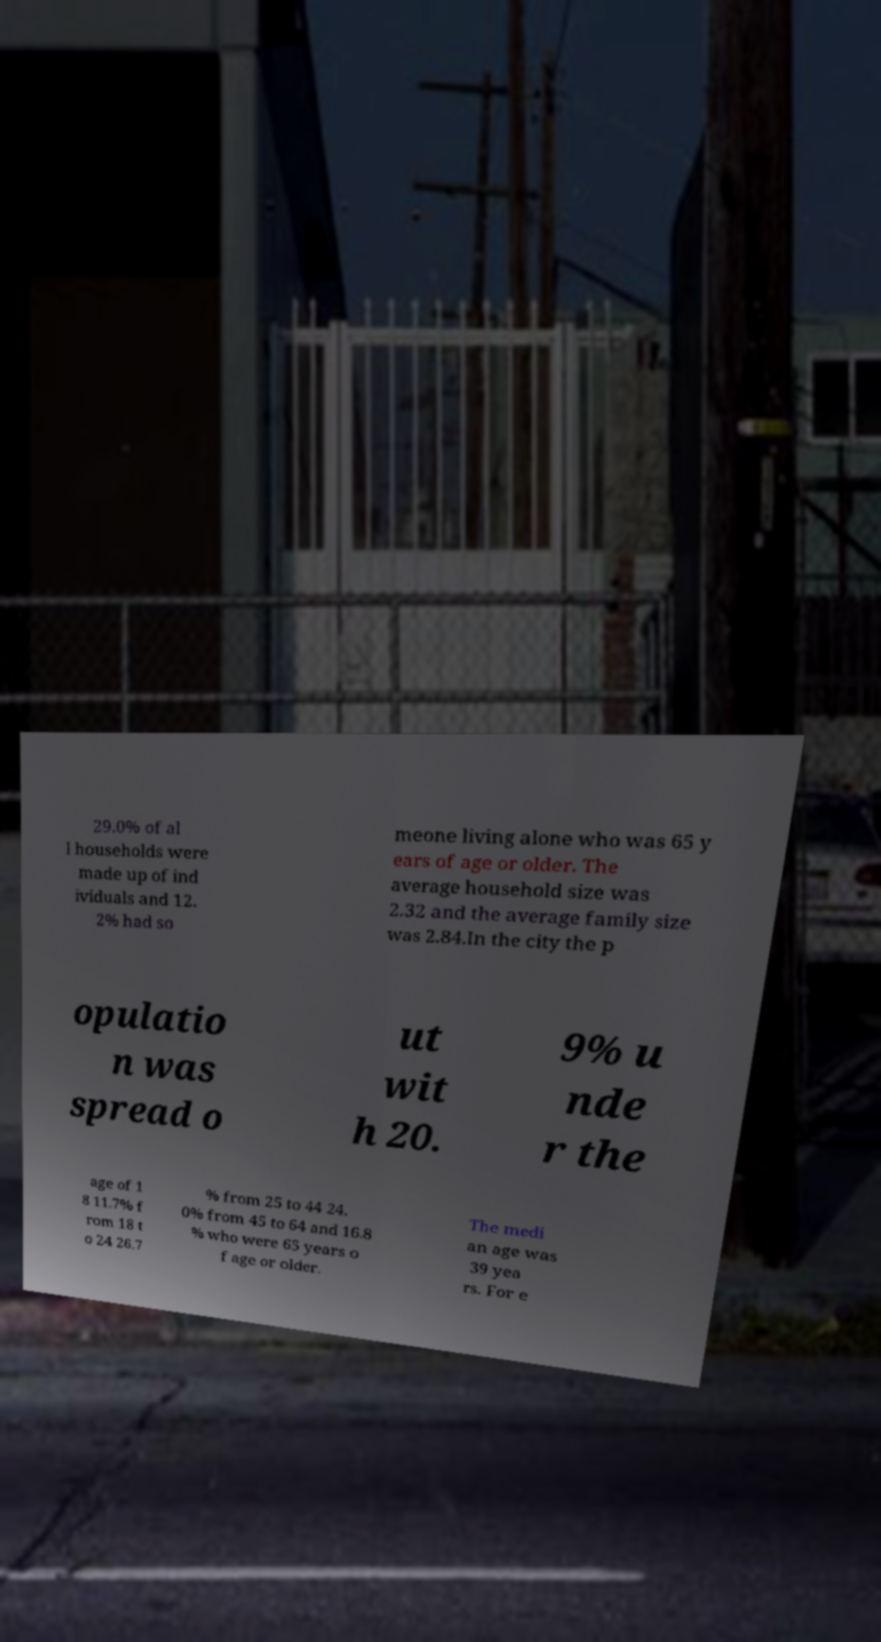For documentation purposes, I need the text within this image transcribed. Could you provide that? 29.0% of al l households were made up of ind ividuals and 12. 2% had so meone living alone who was 65 y ears of age or older. The average household size was 2.32 and the average family size was 2.84.In the city the p opulatio n was spread o ut wit h 20. 9% u nde r the age of 1 8 11.7% f rom 18 t o 24 26.7 % from 25 to 44 24. 0% from 45 to 64 and 16.8 % who were 65 years o f age or older. The medi an age was 39 yea rs. For e 